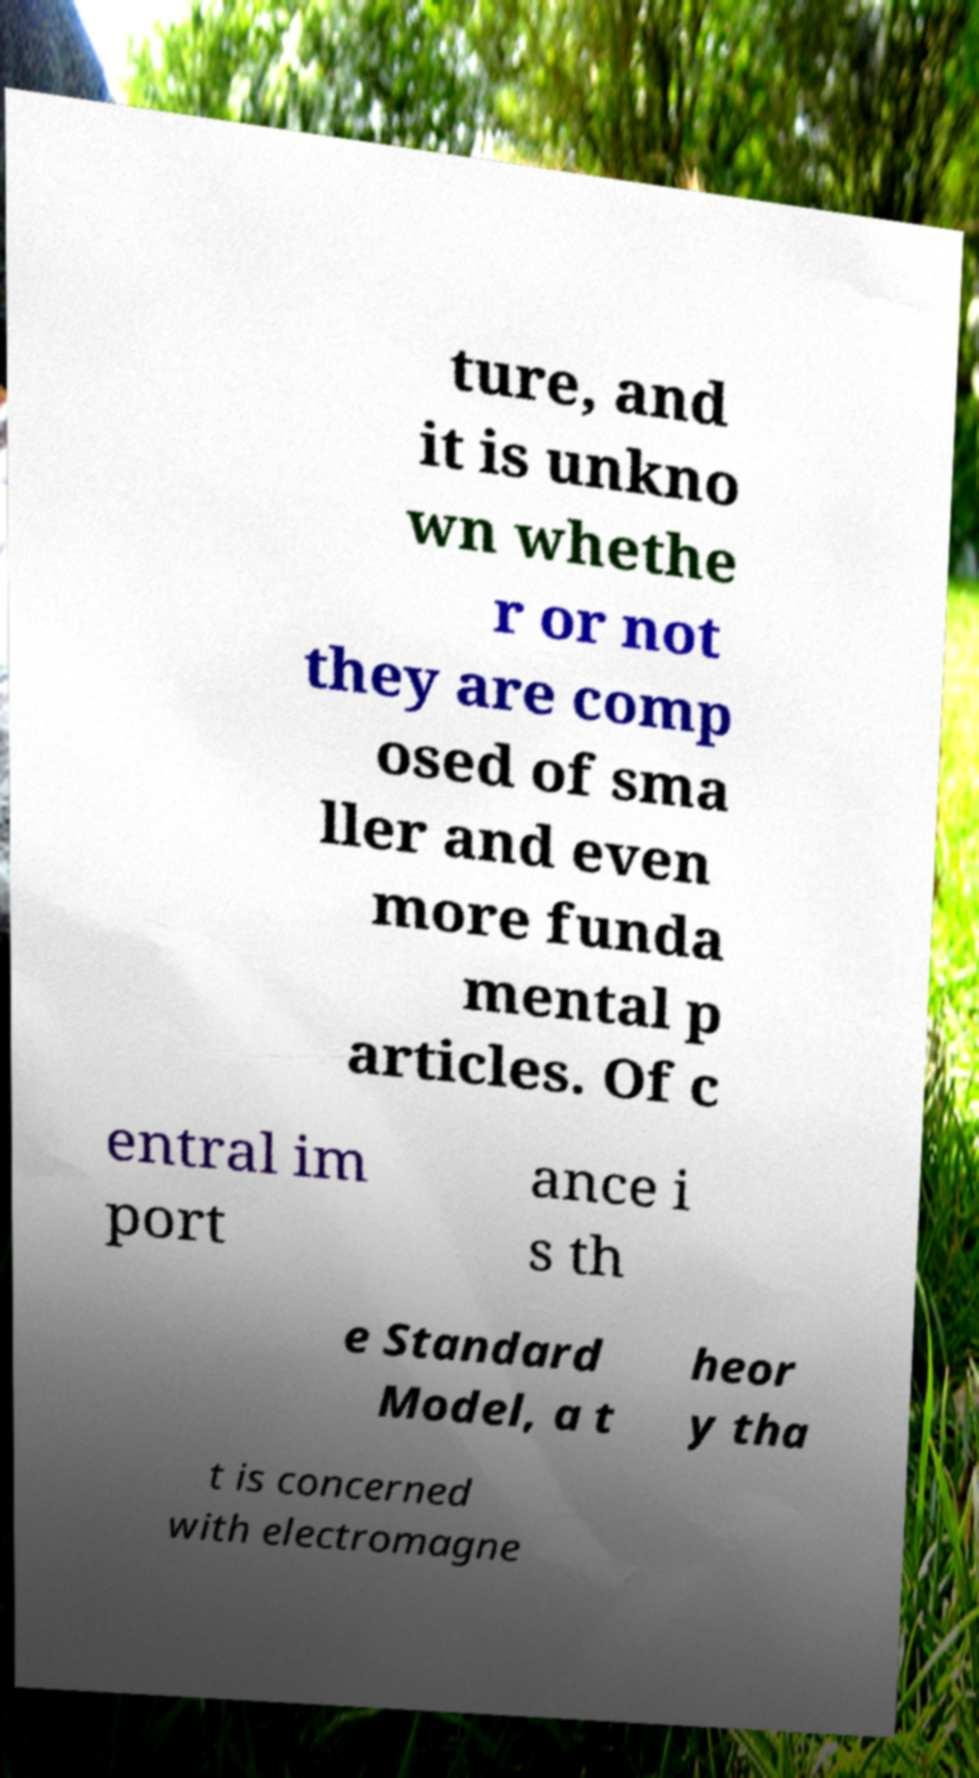Could you assist in decoding the text presented in this image and type it out clearly? ture, and it is unkno wn whethe r or not they are comp osed of sma ller and even more funda mental p articles. Of c entral im port ance i s th e Standard Model, a t heor y tha t is concerned with electromagne 